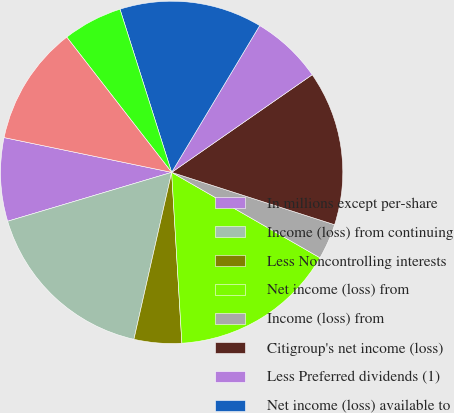Convert chart. <chart><loc_0><loc_0><loc_500><loc_500><pie_chart><fcel>In millions except per-share<fcel>Income (loss) from continuing<fcel>Less Noncontrolling interests<fcel>Net income (loss) from<fcel>Income (loss) from<fcel>Citigroup's net income (loss)<fcel>Less Preferred dividends (1)<fcel>Net income (loss) available to<fcel>Less Dividends and<fcel>Net income (loss) allocated to<nl><fcel>7.87%<fcel>16.85%<fcel>4.49%<fcel>15.73%<fcel>3.37%<fcel>14.61%<fcel>6.74%<fcel>13.48%<fcel>5.62%<fcel>11.24%<nl></chart> 